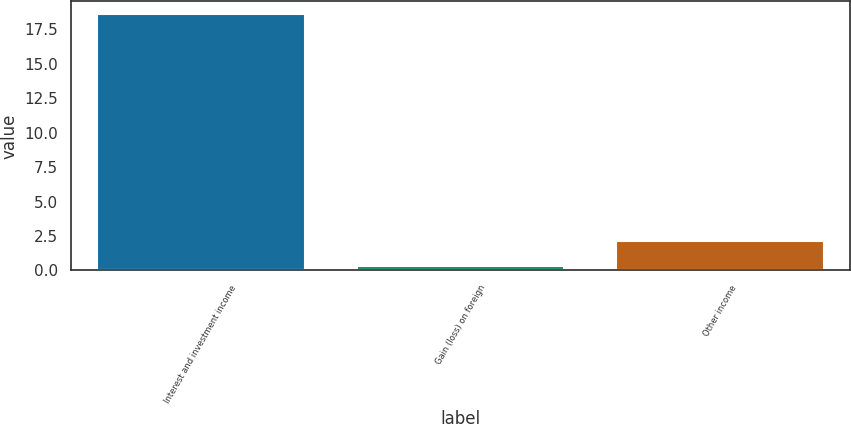Convert chart. <chart><loc_0><loc_0><loc_500><loc_500><bar_chart><fcel>Interest and investment income<fcel>Gain (loss) on foreign<fcel>Other income<nl><fcel>18.6<fcel>0.3<fcel>2.13<nl></chart> 